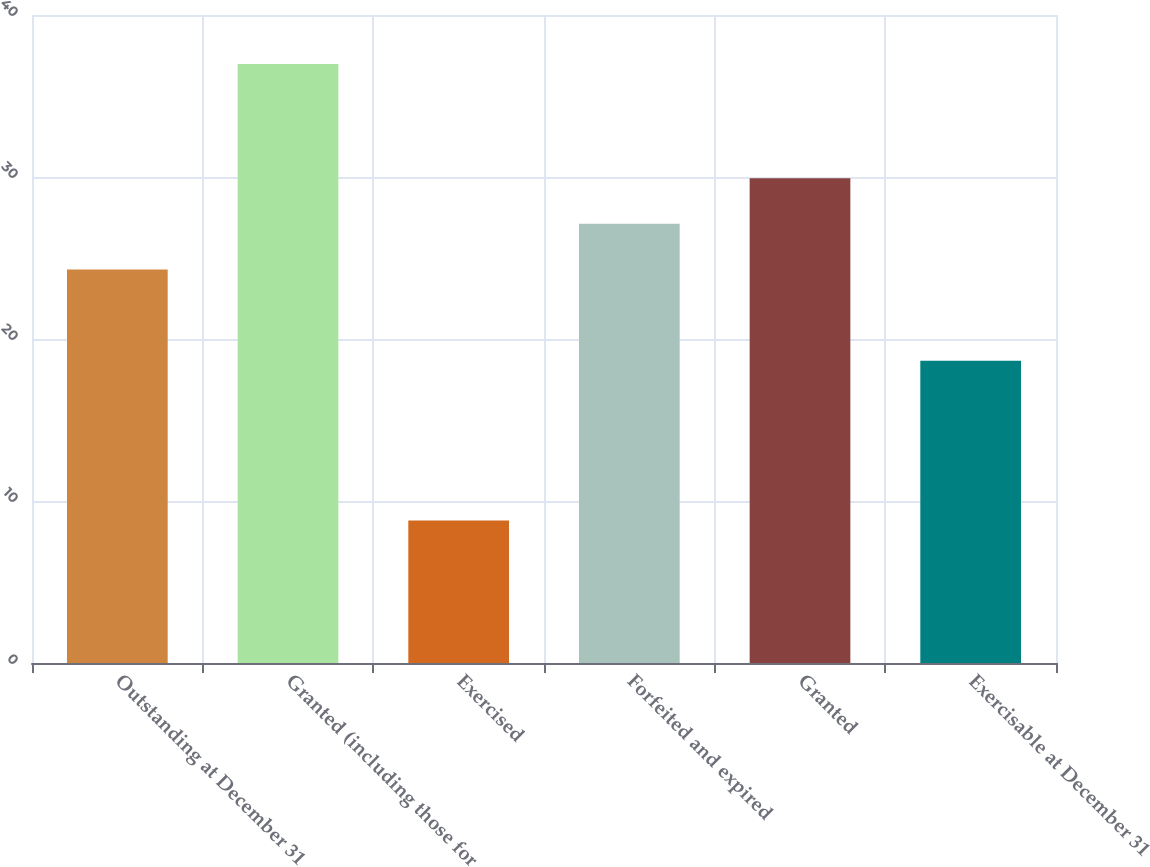Convert chart to OTSL. <chart><loc_0><loc_0><loc_500><loc_500><bar_chart><fcel>Outstanding at December 31<fcel>Granted (including those for<fcel>Exercised<fcel>Forfeited and expired<fcel>Granted<fcel>Exercisable at December 31<nl><fcel>24.29<fcel>36.97<fcel>8.8<fcel>27.11<fcel>29.93<fcel>18.65<nl></chart> 